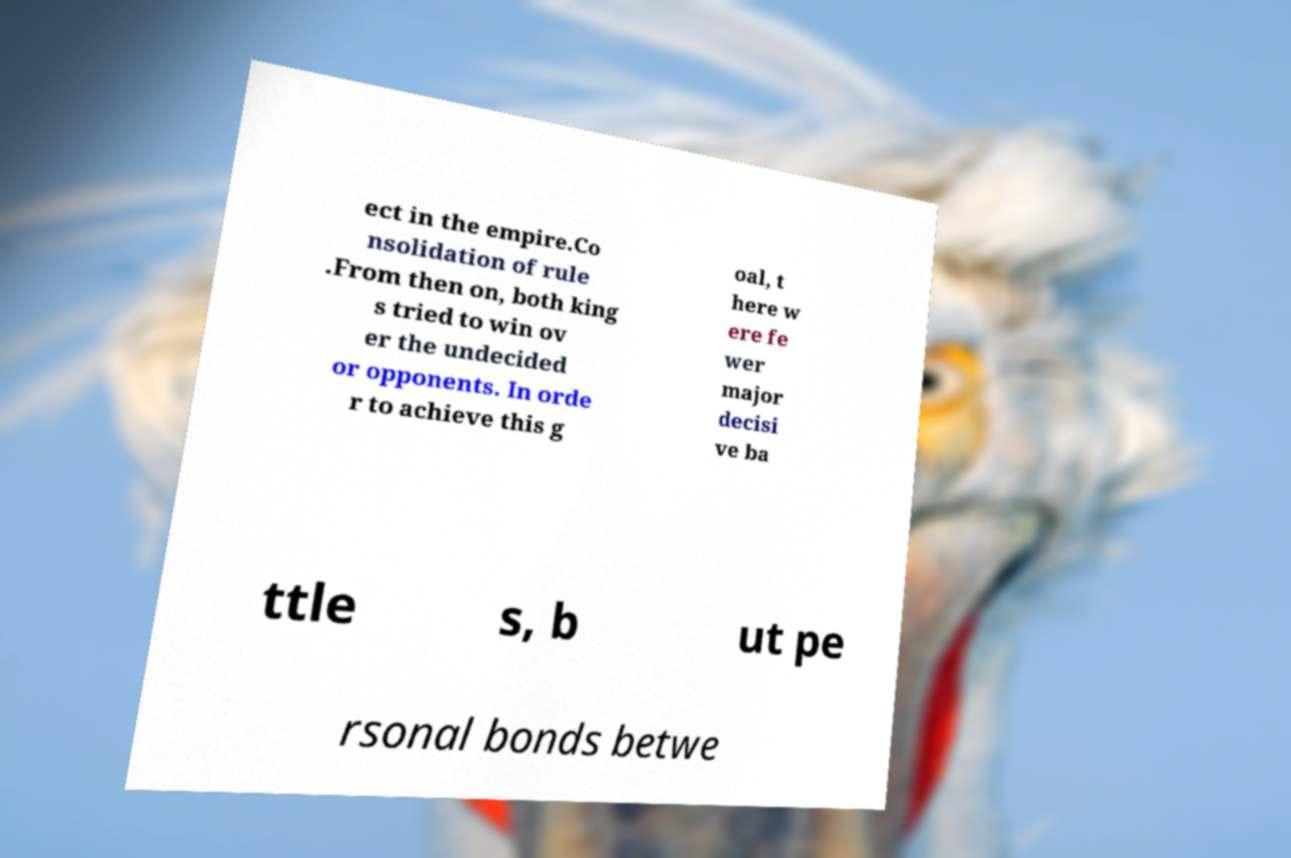Could you extract and type out the text from this image? ect in the empire.Co nsolidation of rule .From then on, both king s tried to win ov er the undecided or opponents. In orde r to achieve this g oal, t here w ere fe wer major decisi ve ba ttle s, b ut pe rsonal bonds betwe 